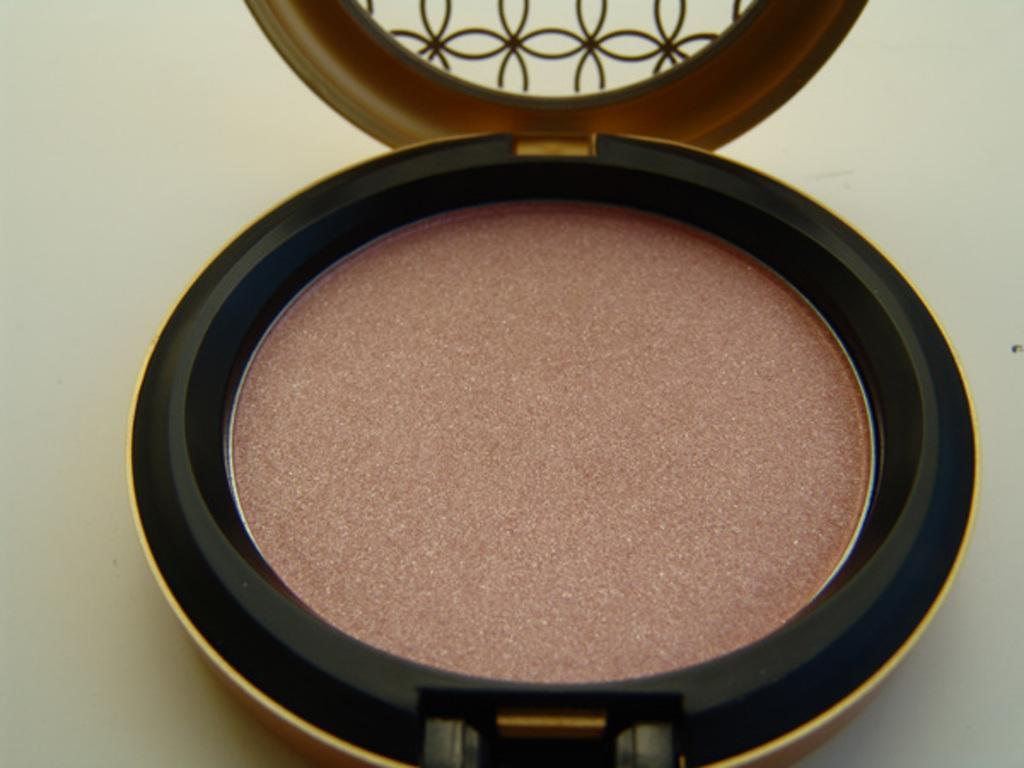What color is the powder in the image? The powder in the image is Rose gold colored. Where is the powder located? The powder is in a compact. What type of net is used for religious purposes in the image? There is no net or religious context present in the image; it features a Rose gold colored powder in a compact. 